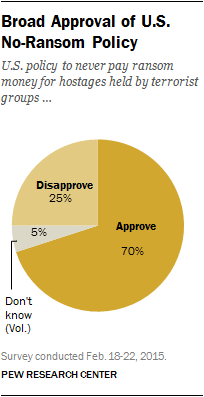Point out several critical features in this image. The value of the largest segment in the graph is 70. 